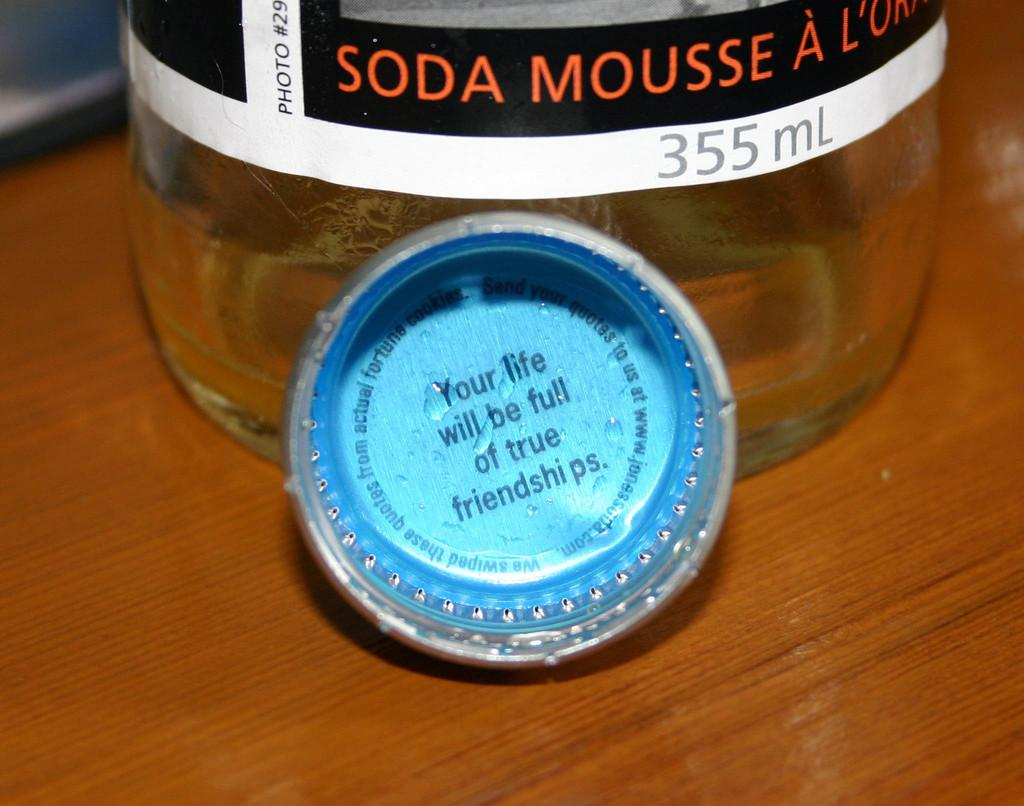Provide a one-sentence caption for the provided image. a close up of soda mousse a with a bottle cap with words about "your life". 